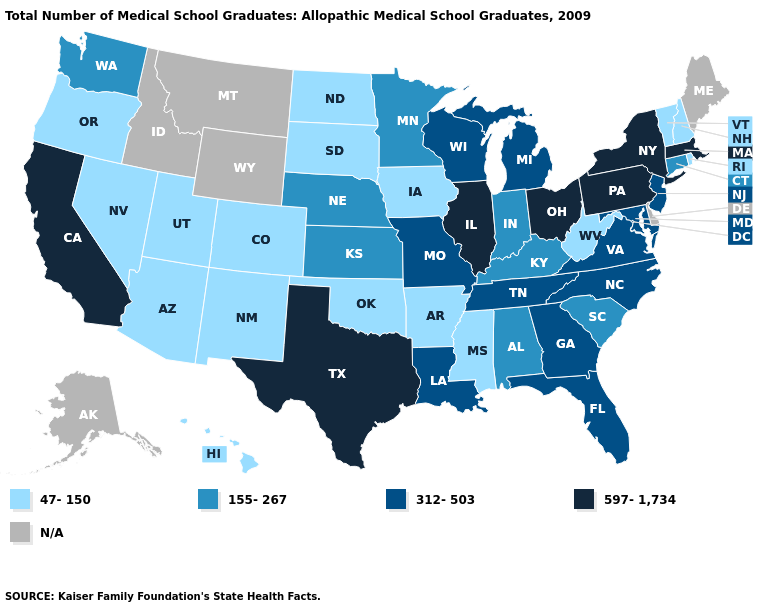Name the states that have a value in the range 47-150?
Answer briefly. Arizona, Arkansas, Colorado, Hawaii, Iowa, Mississippi, Nevada, New Hampshire, New Mexico, North Dakota, Oklahoma, Oregon, Rhode Island, South Dakota, Utah, Vermont, West Virginia. Which states have the lowest value in the USA?
Answer briefly. Arizona, Arkansas, Colorado, Hawaii, Iowa, Mississippi, Nevada, New Hampshire, New Mexico, North Dakota, Oklahoma, Oregon, Rhode Island, South Dakota, Utah, Vermont, West Virginia. What is the value of Washington?
Answer briefly. 155-267. Does South Dakota have the highest value in the USA?
Concise answer only. No. What is the lowest value in the USA?
Keep it brief. 47-150. Among the states that border South Carolina , which have the highest value?
Quick response, please. Georgia, North Carolina. Name the states that have a value in the range N/A?
Quick response, please. Alaska, Delaware, Idaho, Maine, Montana, Wyoming. Name the states that have a value in the range 597-1,734?
Keep it brief. California, Illinois, Massachusetts, New York, Ohio, Pennsylvania, Texas. Name the states that have a value in the range 597-1,734?
Give a very brief answer. California, Illinois, Massachusetts, New York, Ohio, Pennsylvania, Texas. What is the value of Pennsylvania?
Quick response, please. 597-1,734. What is the value of Virginia?
Quick response, please. 312-503. Among the states that border Indiana , does Michigan have the highest value?
Answer briefly. No. Which states have the lowest value in the South?
Concise answer only. Arkansas, Mississippi, Oklahoma, West Virginia. What is the value of Mississippi?
Keep it brief. 47-150. What is the value of Montana?
Answer briefly. N/A. 